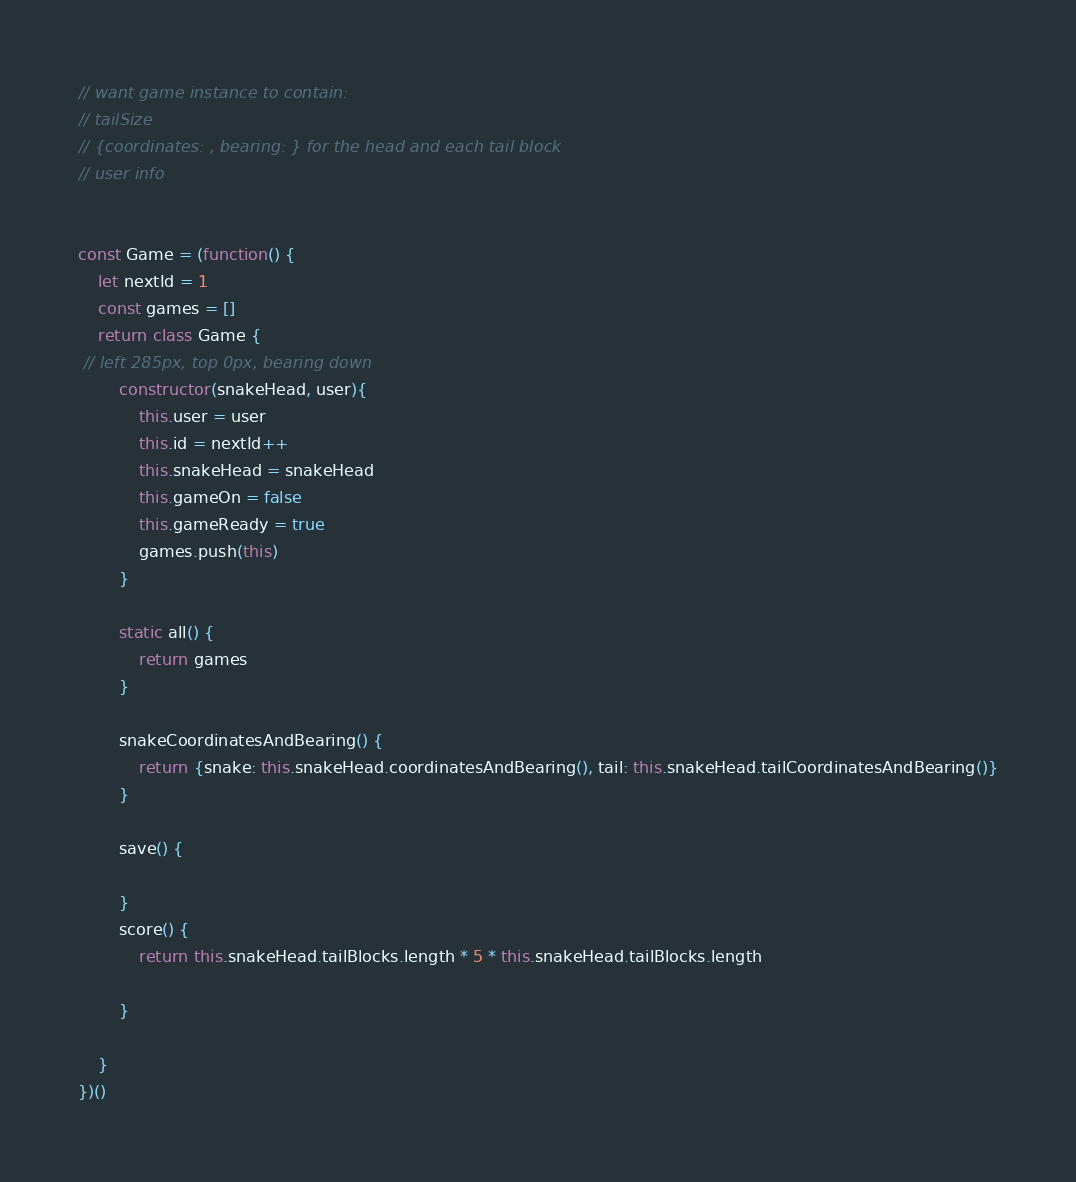Convert code to text. <code><loc_0><loc_0><loc_500><loc_500><_JavaScript_>// want game instance to contain:
// tailSize
// {coordinates: , bearing: } for the head and each tail block
// user info


const Game = (function() {
	let nextId = 1
	const games = []
	return class Game {
 // left 285px, top 0px, bearing down
		constructor(snakeHead, user){
			this.user = user
			this.id = nextId++
			this.snakeHead = snakeHead
			this.gameOn = false
			this.gameReady = true
			games.push(this)
		}

		static all() {
			return games
		}

		snakeCoordinatesAndBearing() {
			return {snake: this.snakeHead.coordinatesAndBearing(), tail: this.snakeHead.tailCoordinatesAndBearing()}
		}

	 	save() {

		}
		score() {
			return this.snakeHead.tailBlocks.length * 5 * this.snakeHead.tailBlocks.length

		}

	}
})()
</code> 